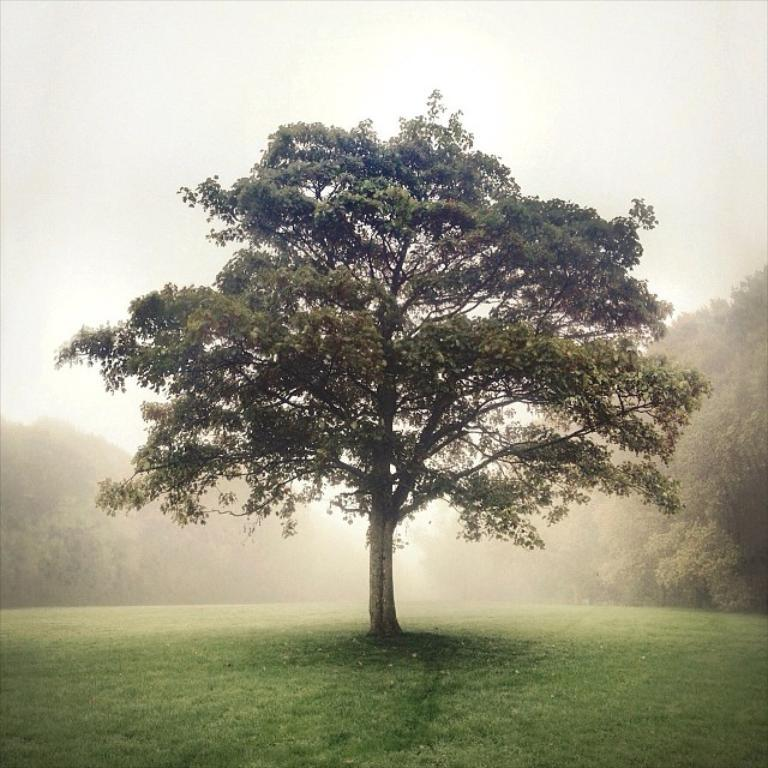What type of vegetation can be seen in the image? There are trees in the image. What is visible at the top of the image? The sky is visible at the top of the image. What is visible at the bottom of the image? The ground is visible at the bottom of the image. Can you see any clovers growing near the trees in the image? There is no mention of clovers in the image, so it cannot be determined if they are present. Is there a volcano visible in the image? There is no volcano present in the image. Can you see the moon in the sky in the image? The sky is visible in the image, but there is no mention of the moon, so it cannot be determined if it is present. 